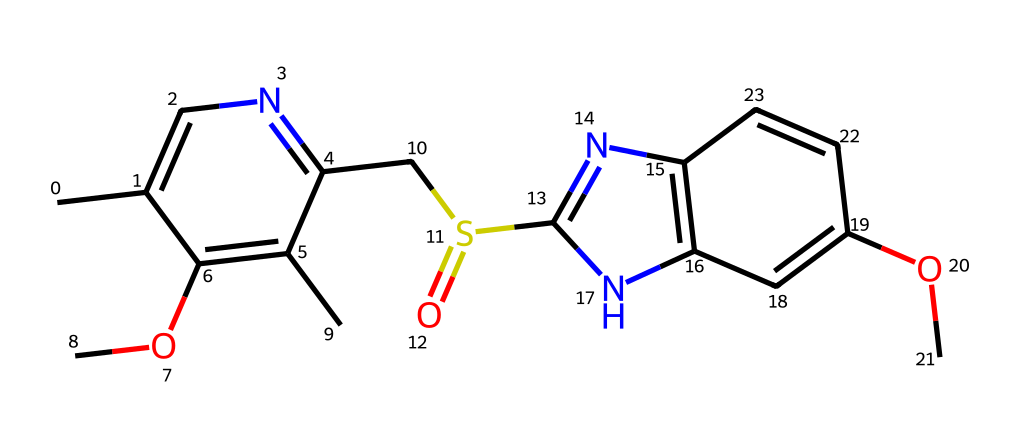How many carbon atoms are present in omeprazole? In the provided SMILES representation, we can visually count the number of 'C' characters, which represent carbon atoms. By examining the structure, there are 14 carbon atoms in total.
Answer: 14 What type of functional group is represented by 'S(=O)' in the structure? The 'S(=O)' notation indicates the presence of a sulfonyl group, which consists of a sulfur atom bonded to two oxygen atoms, one of which is double-bonded. This is characteristic of sulfonic acids or sulfonamides.
Answer: sulfonyl Which ring system is present in omeprazole? By analyzing the structure, we can see that the chemical features a fused bicyclic structure consisting of a five-membered ring with nitrogen atoms, which is characteristic of benzothiazoles or related heterocycles.
Answer: bicyclic How many nitrogen atoms are in omeprazole? The nitrogen atoms are represented in the chemical structure with the 'N' characters. By counting these, we find 4 nitrogen atoms present in omeprazole.
Answer: 4 What kind of compound is omeprazole classified as? Omeprazole is classified as a proton pump inhibitor, which functions as a medication to reduce stomach acid production. The presence of the sulfonyl and aromatic systems indicates its medicinal properties related to acidity.
Answer: proton pump inhibitor What is the degree of unsaturation in omeprazole? To determine the degree of unsaturation, we can count the rings and double bonds in the structure. Each ring or double bond contributes to the degree of unsaturation. In this molecule, there are 4 double bonds and at least 2 rings, giving a total degree of unsaturation of 6.
Answer: 6 Does omeprazole contain any oxygen atoms? We identify the presence of oxygen atoms by looking for 'O' in the SMILES notation. The structure shows several oxygen atoms in different parts of the molecule, notably grouped in functional groups. There are 3 oxygen atoms in total.
Answer: 3 